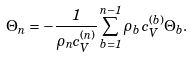Convert formula to latex. <formula><loc_0><loc_0><loc_500><loc_500>\Theta _ { n } = - \frac { 1 } { \rho _ { n } c _ { V } ^ { ( n ) } } \sum _ { b = 1 } ^ { n - 1 } \rho _ { b } \, c _ { V } ^ { ( b ) } \Theta _ { b } .</formula> 